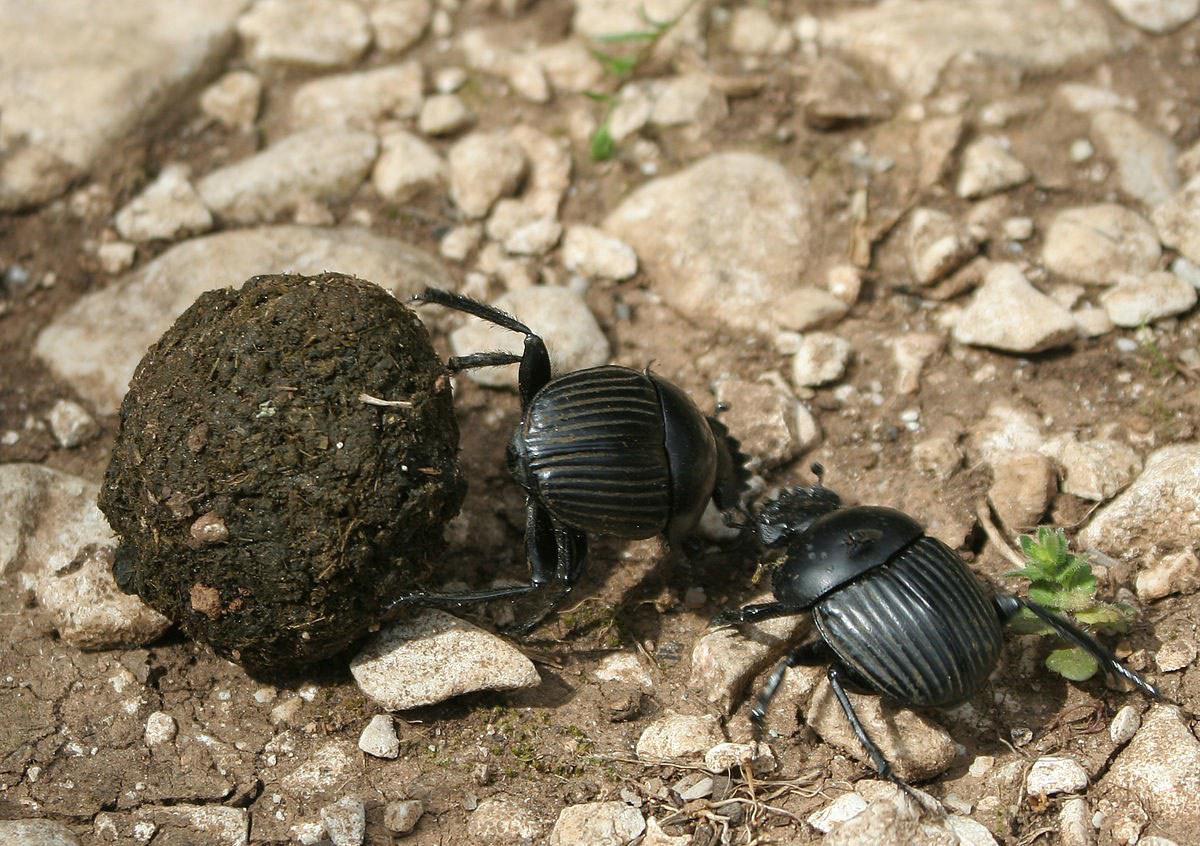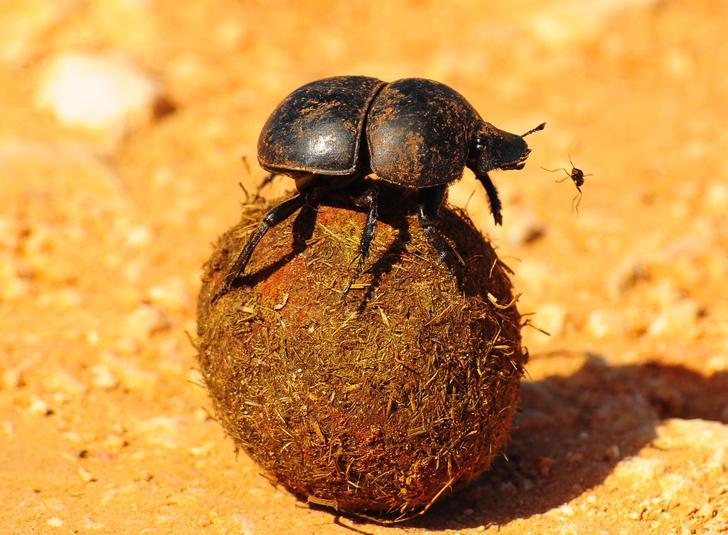The first image is the image on the left, the second image is the image on the right. Given the left and right images, does the statement "At least one image shows a beetle with a large horn." hold true? Answer yes or no. No. 